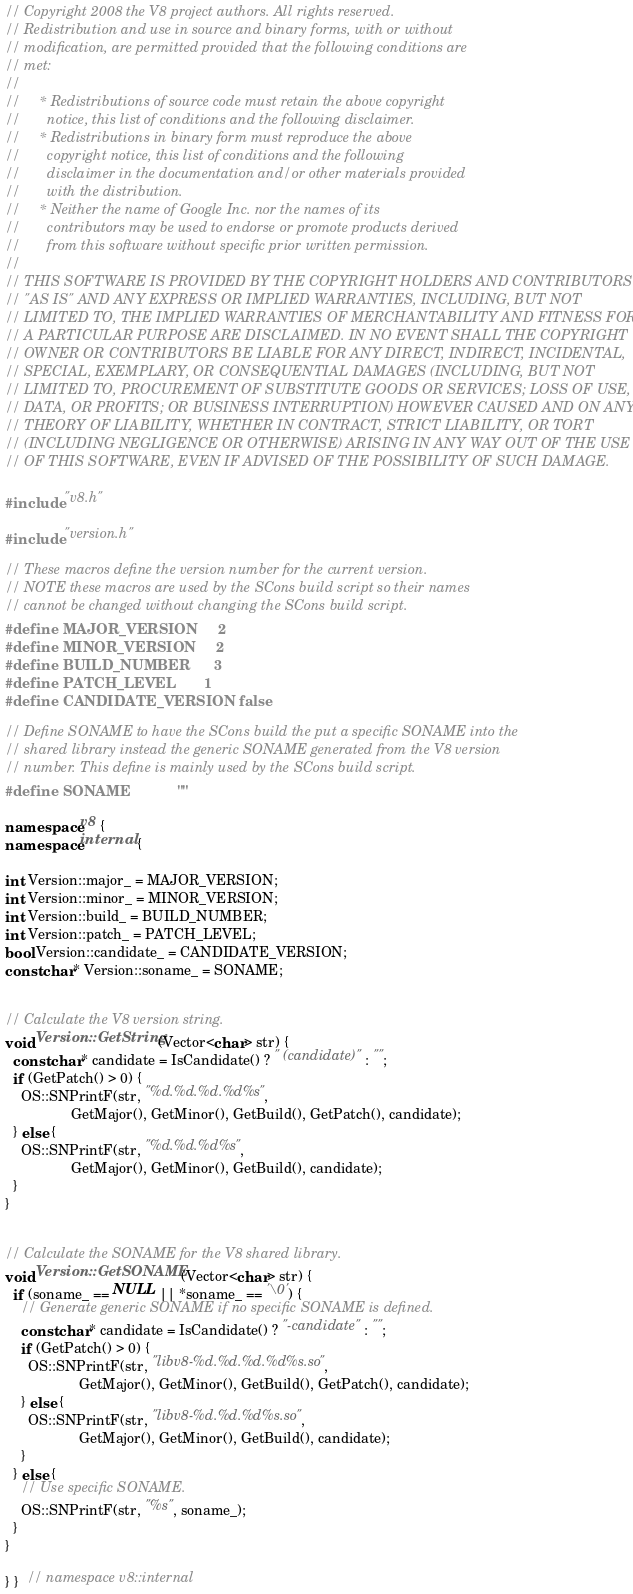<code> <loc_0><loc_0><loc_500><loc_500><_C++_>// Copyright 2008 the V8 project authors. All rights reserved.
// Redistribution and use in source and binary forms, with or without
// modification, are permitted provided that the following conditions are
// met:
//
//     * Redistributions of source code must retain the above copyright
//       notice, this list of conditions and the following disclaimer.
//     * Redistributions in binary form must reproduce the above
//       copyright notice, this list of conditions and the following
//       disclaimer in the documentation and/or other materials provided
//       with the distribution.
//     * Neither the name of Google Inc. nor the names of its
//       contributors may be used to endorse or promote products derived
//       from this software without specific prior written permission.
//
// THIS SOFTWARE IS PROVIDED BY THE COPYRIGHT HOLDERS AND CONTRIBUTORS
// "AS IS" AND ANY EXPRESS OR IMPLIED WARRANTIES, INCLUDING, BUT NOT
// LIMITED TO, THE IMPLIED WARRANTIES OF MERCHANTABILITY AND FITNESS FOR
// A PARTICULAR PURPOSE ARE DISCLAIMED. IN NO EVENT SHALL THE COPYRIGHT
// OWNER OR CONTRIBUTORS BE LIABLE FOR ANY DIRECT, INDIRECT, INCIDENTAL,
// SPECIAL, EXEMPLARY, OR CONSEQUENTIAL DAMAGES (INCLUDING, BUT NOT
// LIMITED TO, PROCUREMENT OF SUBSTITUTE GOODS OR SERVICES; LOSS OF USE,
// DATA, OR PROFITS; OR BUSINESS INTERRUPTION) HOWEVER CAUSED AND ON ANY
// THEORY OF LIABILITY, WHETHER IN CONTRACT, STRICT LIABILITY, OR TORT
// (INCLUDING NEGLIGENCE OR OTHERWISE) ARISING IN ANY WAY OUT OF THE USE
// OF THIS SOFTWARE, EVEN IF ADVISED OF THE POSSIBILITY OF SUCH DAMAGE.

#include "v8.h"

#include "version.h"

// These macros define the version number for the current version.
// NOTE these macros are used by the SCons build script so their names
// cannot be changed without changing the SCons build script.
#define MAJOR_VERSION     2
#define MINOR_VERSION     2
#define BUILD_NUMBER      3
#define PATCH_LEVEL       1
#define CANDIDATE_VERSION false

// Define SONAME to have the SCons build the put a specific SONAME into the
// shared library instead the generic SONAME generated from the V8 version
// number. This define is mainly used by the SCons build script.
#define SONAME            ""

namespace v8 {
namespace internal {

int Version::major_ = MAJOR_VERSION;
int Version::minor_ = MINOR_VERSION;
int Version::build_ = BUILD_NUMBER;
int Version::patch_ = PATCH_LEVEL;
bool Version::candidate_ = CANDIDATE_VERSION;
const char* Version::soname_ = SONAME;


// Calculate the V8 version string.
void Version::GetString(Vector<char> str) {
  const char* candidate = IsCandidate() ? " (candidate)" : "";
  if (GetPatch() > 0) {
    OS::SNPrintF(str, "%d.%d.%d.%d%s",
                 GetMajor(), GetMinor(), GetBuild(), GetPatch(), candidate);
  } else {
    OS::SNPrintF(str, "%d.%d.%d%s",
                 GetMajor(), GetMinor(), GetBuild(), candidate);
  }
}


// Calculate the SONAME for the V8 shared library.
void Version::GetSONAME(Vector<char> str) {
  if (soname_ == NULL || *soname_ == '\0') {
    // Generate generic SONAME if no specific SONAME is defined.
    const char* candidate = IsCandidate() ? "-candidate" : "";
    if (GetPatch() > 0) {
      OS::SNPrintF(str, "libv8-%d.%d.%d.%d%s.so",
                   GetMajor(), GetMinor(), GetBuild(), GetPatch(), candidate);
    } else {
      OS::SNPrintF(str, "libv8-%d.%d.%d%s.so",
                   GetMajor(), GetMinor(), GetBuild(), candidate);
    }
  } else {
    // Use specific SONAME.
    OS::SNPrintF(str, "%s", soname_);
  }
}

} }  // namespace v8::internal
</code> 